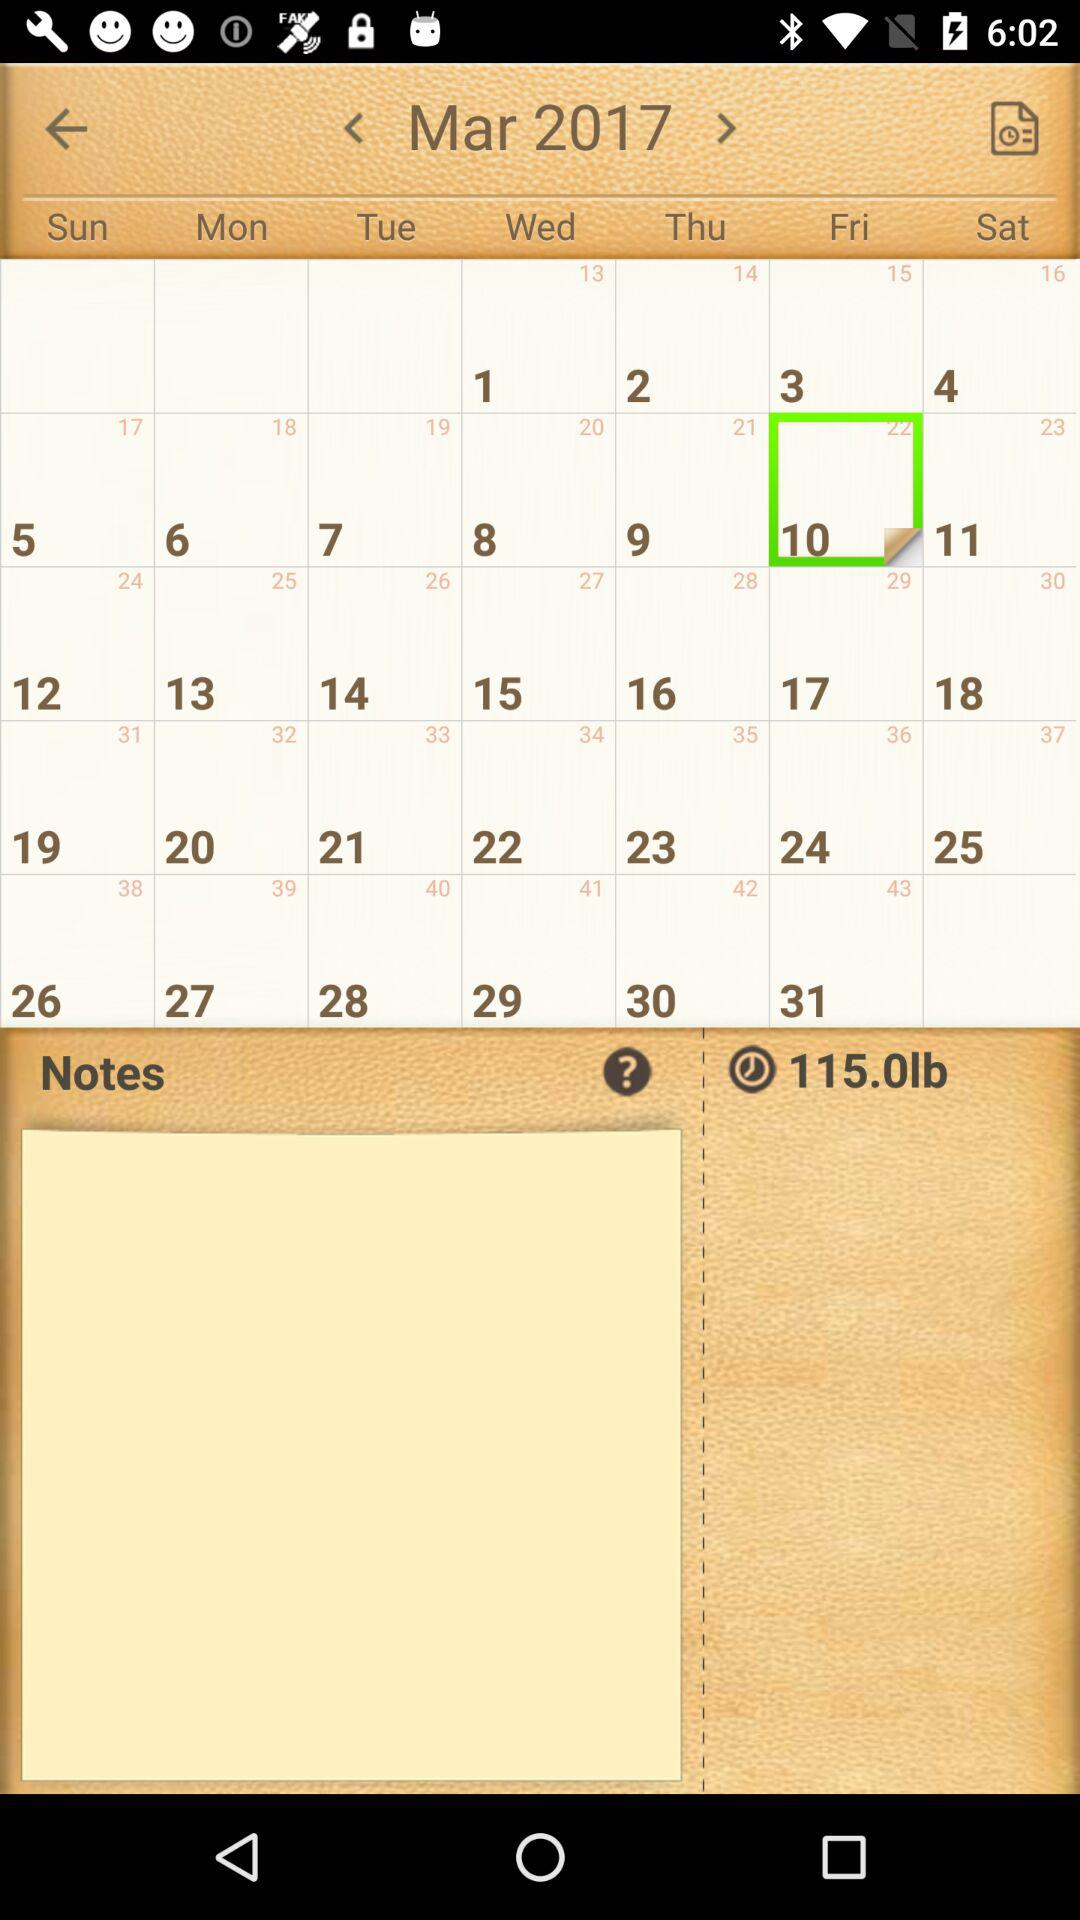Which date has been selected? The selected date is Friday, March 10, 2017. 